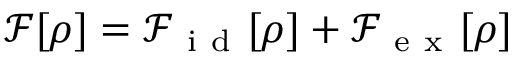Convert formula to latex. <formula><loc_0><loc_0><loc_500><loc_500>\mathcal { F } [ \rho ] = \mathcal { F } _ { i d } [ \rho ] + \mathcal { F } _ { e x } [ \rho ]</formula> 